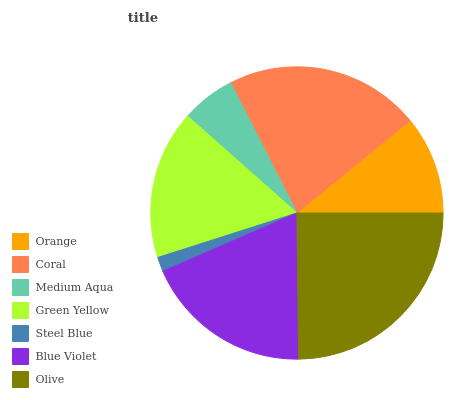Is Steel Blue the minimum?
Answer yes or no. Yes. Is Olive the maximum?
Answer yes or no. Yes. Is Coral the minimum?
Answer yes or no. No. Is Coral the maximum?
Answer yes or no. No. Is Coral greater than Orange?
Answer yes or no. Yes. Is Orange less than Coral?
Answer yes or no. Yes. Is Orange greater than Coral?
Answer yes or no. No. Is Coral less than Orange?
Answer yes or no. No. Is Green Yellow the high median?
Answer yes or no. Yes. Is Green Yellow the low median?
Answer yes or no. Yes. Is Medium Aqua the high median?
Answer yes or no. No. Is Steel Blue the low median?
Answer yes or no. No. 